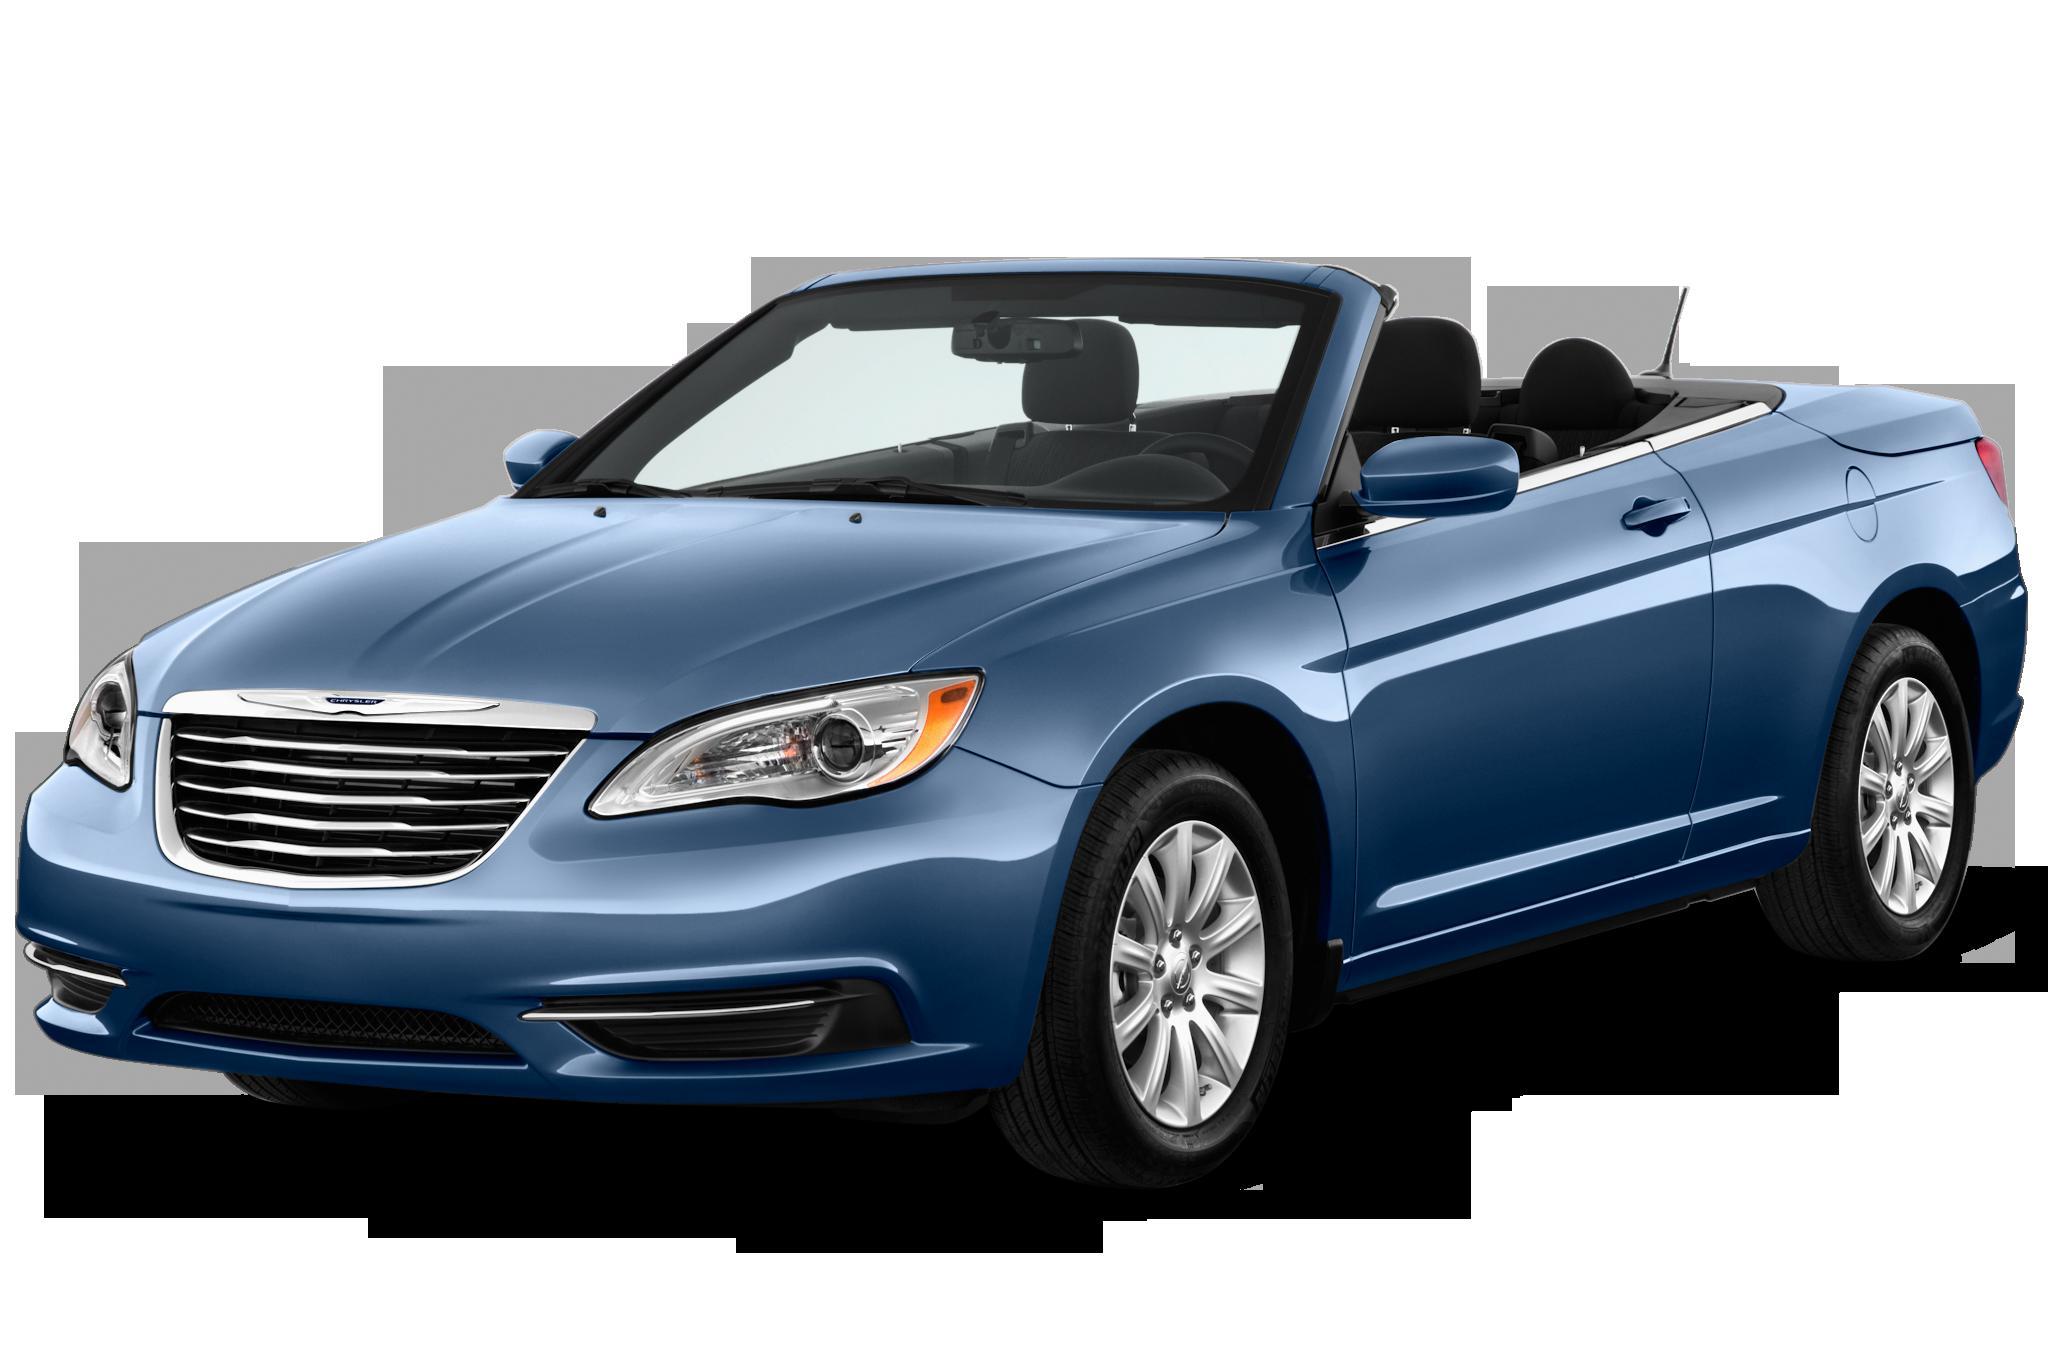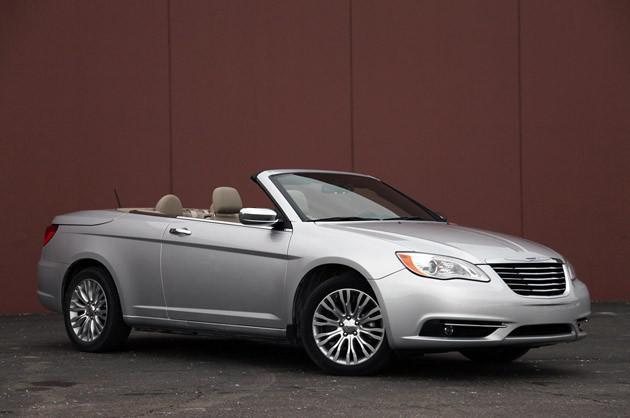The first image is the image on the left, the second image is the image on the right. Assess this claim about the two images: "The left image contains only one car and it is blue.". Correct or not? Answer yes or no. Yes. The first image is the image on the left, the second image is the image on the right. Examine the images to the left and right. Is the description "In the left image, there is a single blue convertible with its top down" accurate? Answer yes or no. Yes. 